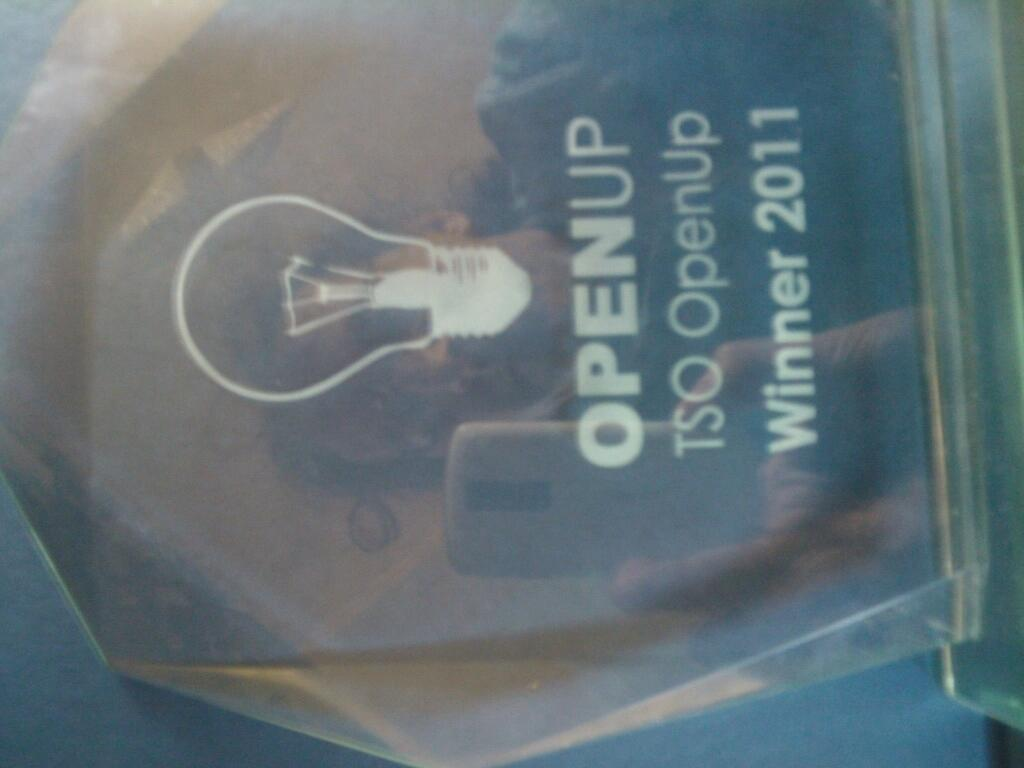<image>
Relay a brief, clear account of the picture shown. An award that says OPENUP Winner 2011 on it. 